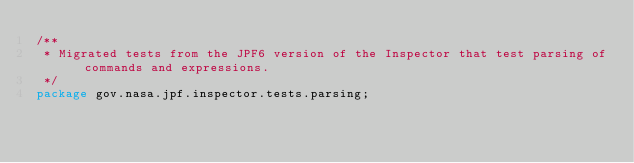<code> <loc_0><loc_0><loc_500><loc_500><_Java_>/**
 * Migrated tests from the JPF6 version of the Inspector that test parsing of commands and expressions.
 */
package gov.nasa.jpf.inspector.tests.parsing;</code> 